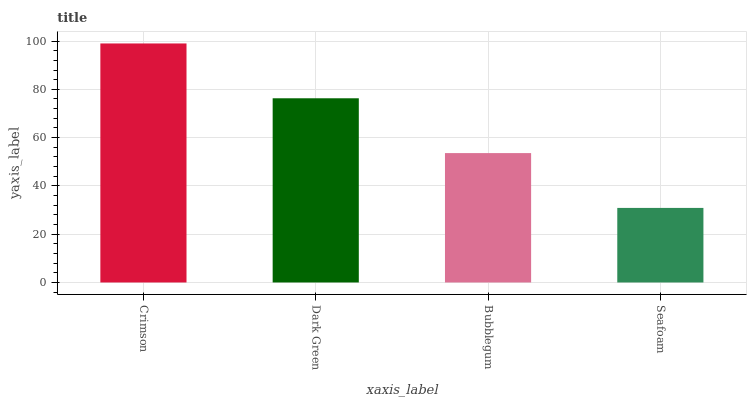Is Seafoam the minimum?
Answer yes or no. Yes. Is Crimson the maximum?
Answer yes or no. Yes. Is Dark Green the minimum?
Answer yes or no. No. Is Dark Green the maximum?
Answer yes or no. No. Is Crimson greater than Dark Green?
Answer yes or no. Yes. Is Dark Green less than Crimson?
Answer yes or no. Yes. Is Dark Green greater than Crimson?
Answer yes or no. No. Is Crimson less than Dark Green?
Answer yes or no. No. Is Dark Green the high median?
Answer yes or no. Yes. Is Bubblegum the low median?
Answer yes or no. Yes. Is Crimson the high median?
Answer yes or no. No. Is Seafoam the low median?
Answer yes or no. No. 